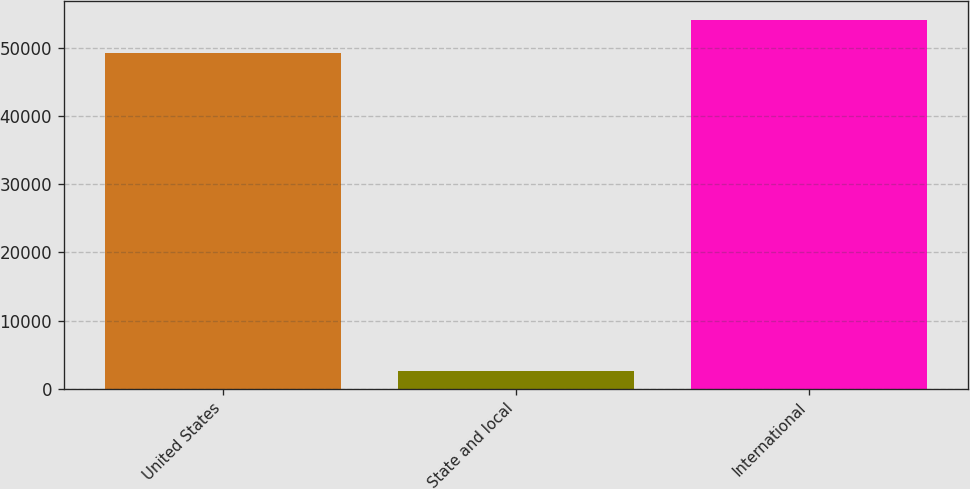Convert chart to OTSL. <chart><loc_0><loc_0><loc_500><loc_500><bar_chart><fcel>United States<fcel>State and local<fcel>International<nl><fcel>49233<fcel>2538<fcel>54196.8<nl></chart> 